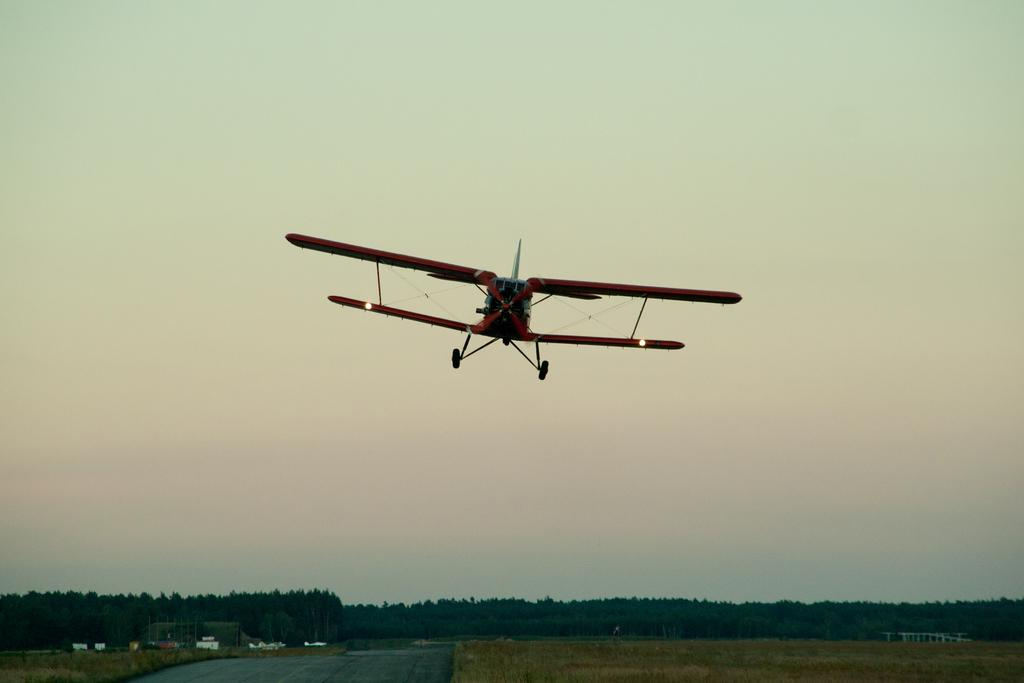What is the main subject in the center of the image? There is an aircraft in the center of the image. What can be seen in the background of the image? There are trees and some objects in the background of the image. What part of the natural environment is visible in the image? The sky is visible in the background of the image. What type of protest is taking place in the image? There is no protest present in the image; it features an aircraft and a background with trees, objects, and the sky. How many men can be seen participating in the market in the image? There is no market or men present in the image. 